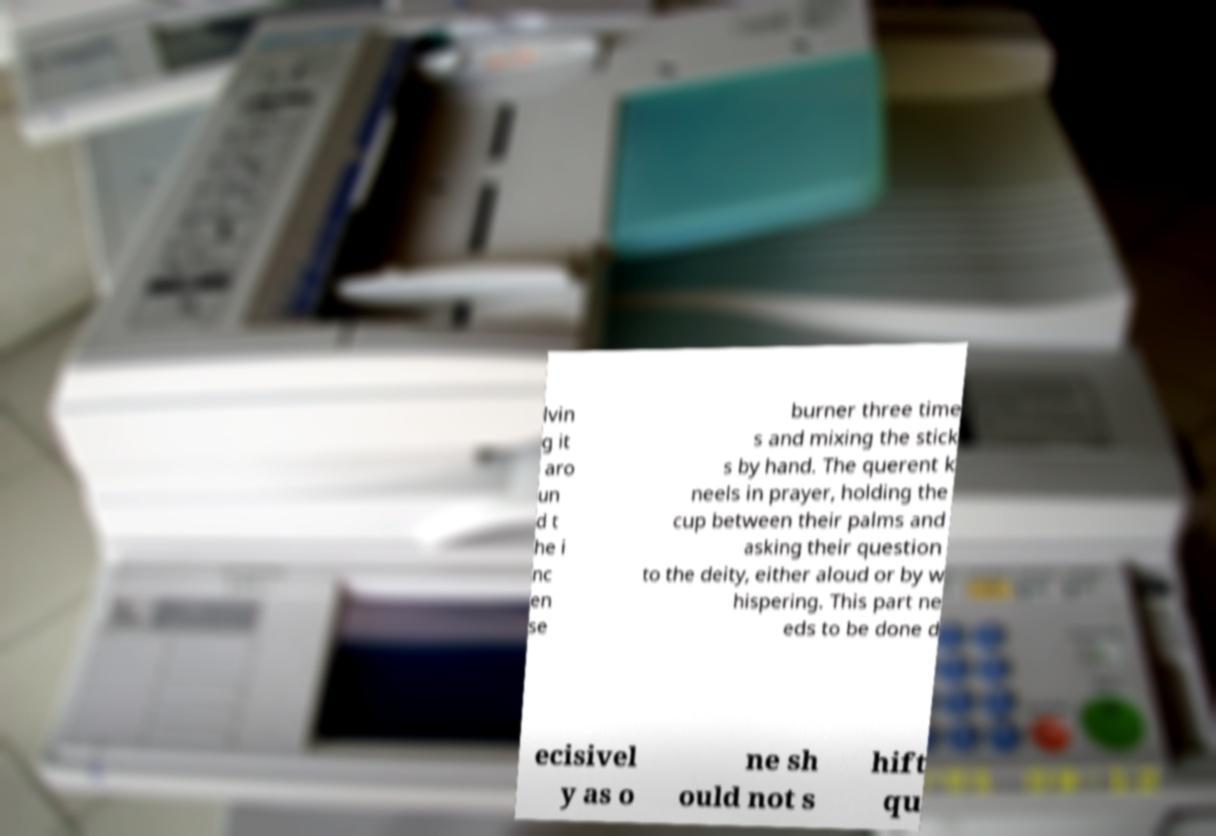Could you assist in decoding the text presented in this image and type it out clearly? lvin g it aro un d t he i nc en se burner three time s and mixing the stick s by hand. The querent k neels in prayer, holding the cup between their palms and asking their question to the deity, either aloud or by w hispering. This part ne eds to be done d ecisivel y as o ne sh ould not s hift qu 